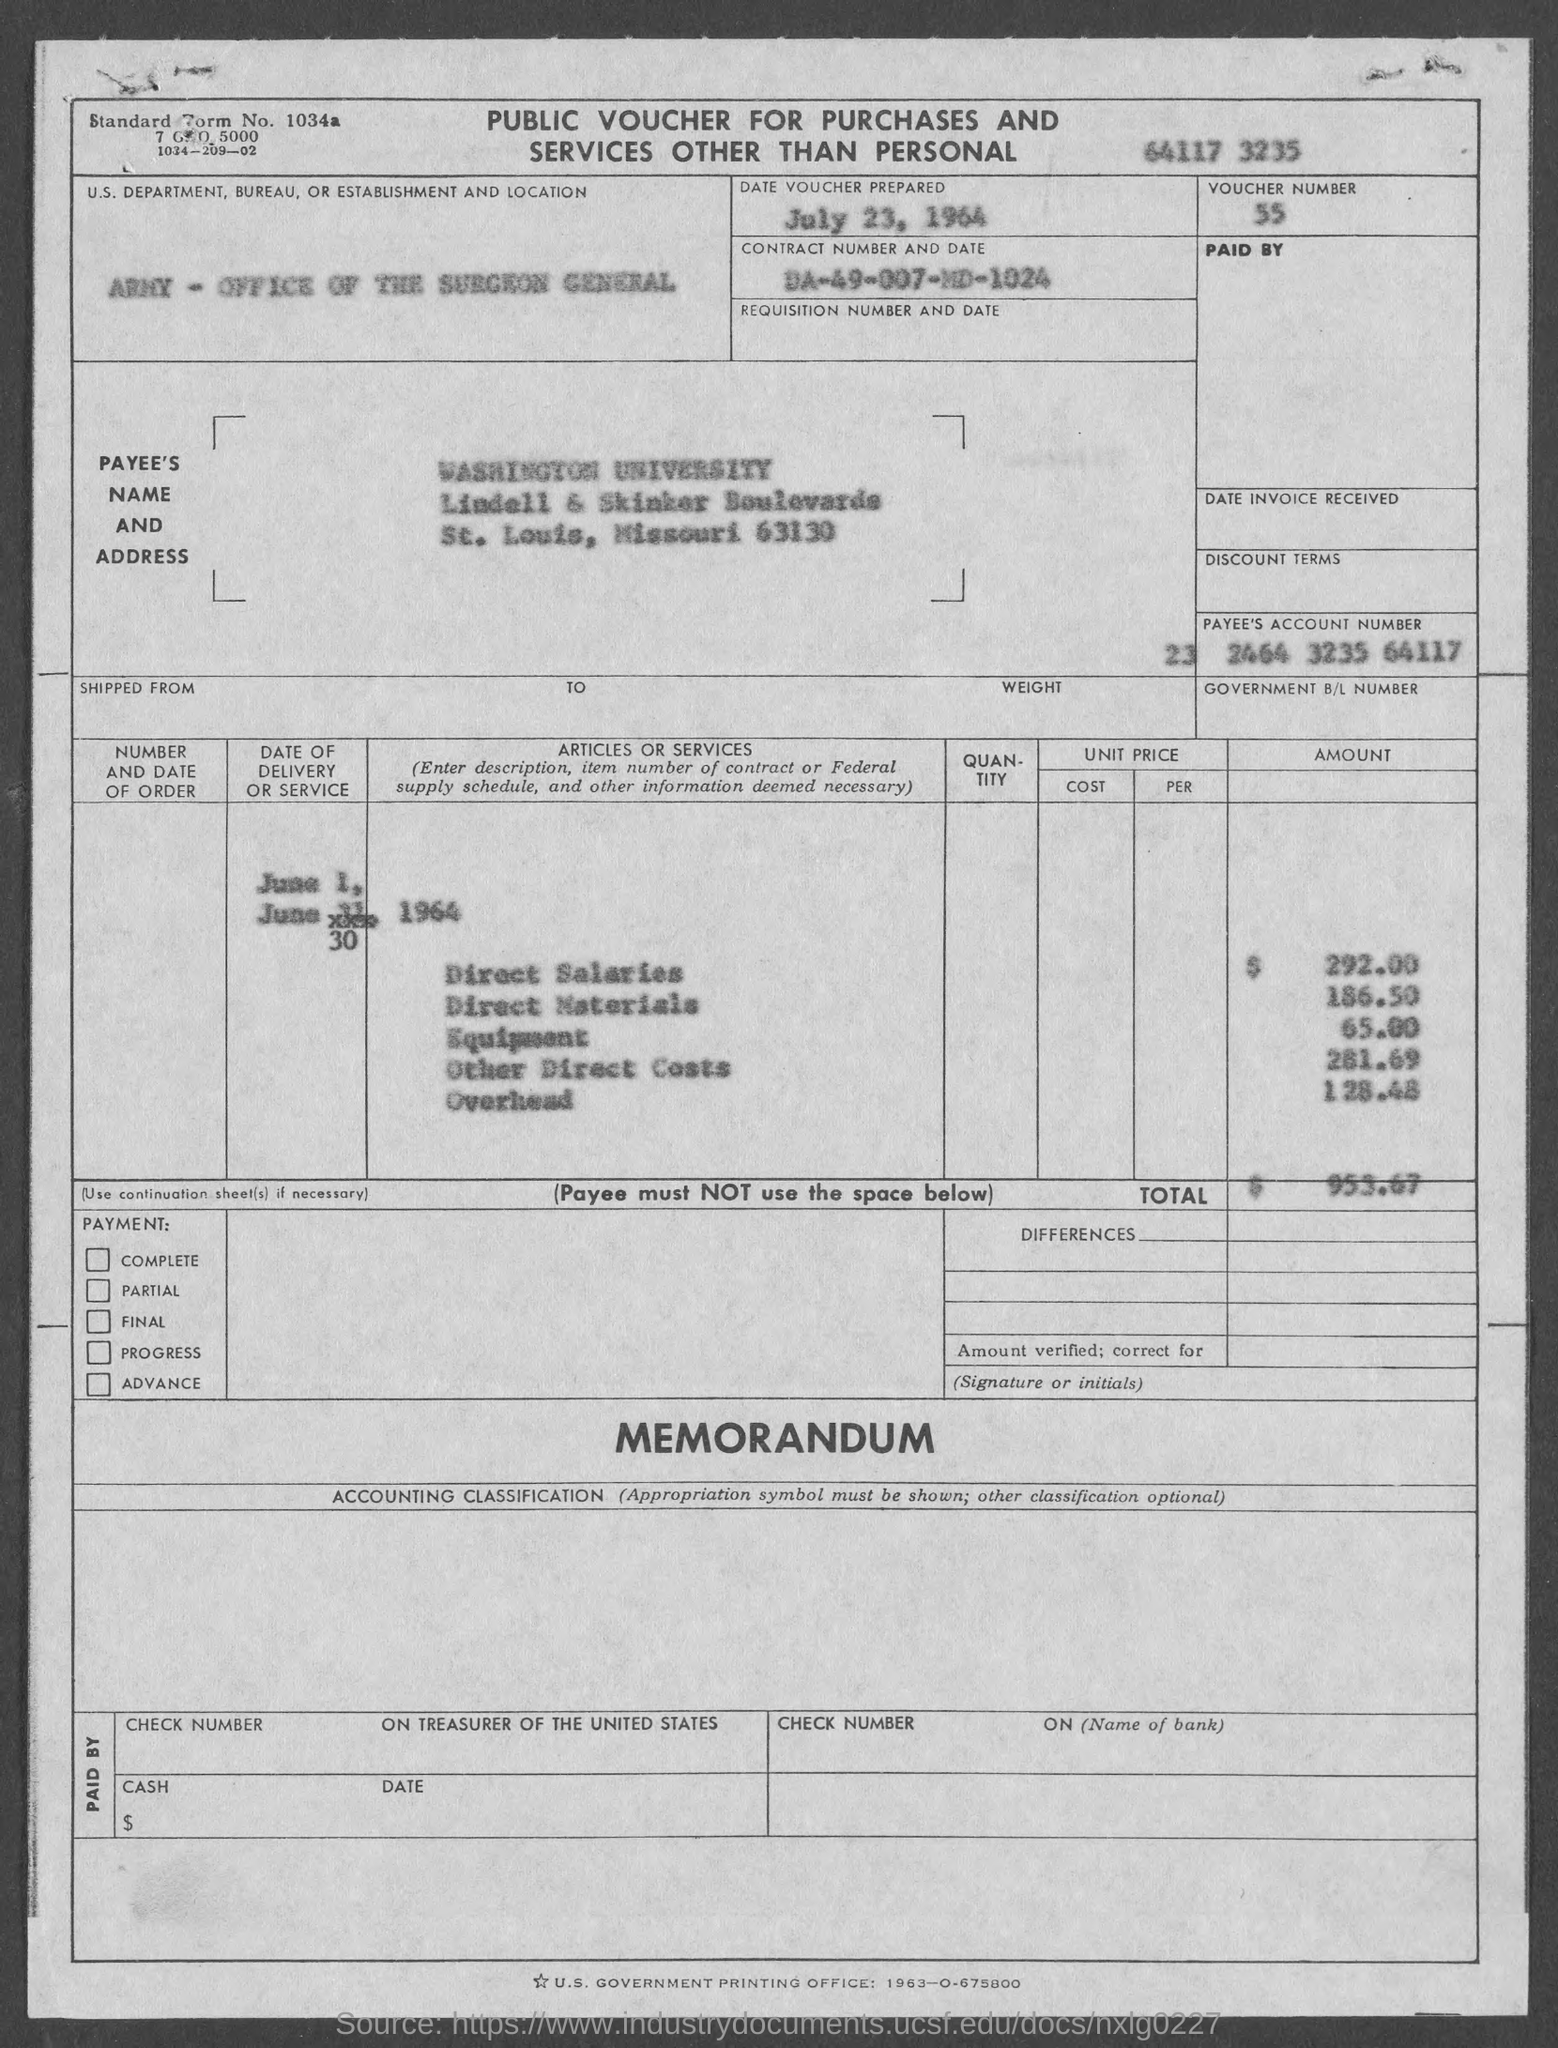What is the Standard Form No. given in the voucher?
Your response must be concise. 1034a. What type of voucher is given here?
Give a very brief answer. PUBLIC VOUCHER FOR PURCHASES AND SERVICES OTHER THAN PERSONAL. What is the date of voucher prepared?
Offer a terse response. July 23, 1964. What is the Payee name given in the voucher?
Provide a short and direct response. WASHINGTON UNIVERSITY. What is the Payee's Account No. given in the voucher?
Your answer should be very brief. 23 2464 3235 64117. What is the direct salaries cost mentioned in the voucher?
Your answer should be compact. $ 292.00. What is the total amount given in the voucher?
Your response must be concise. 953.67. 